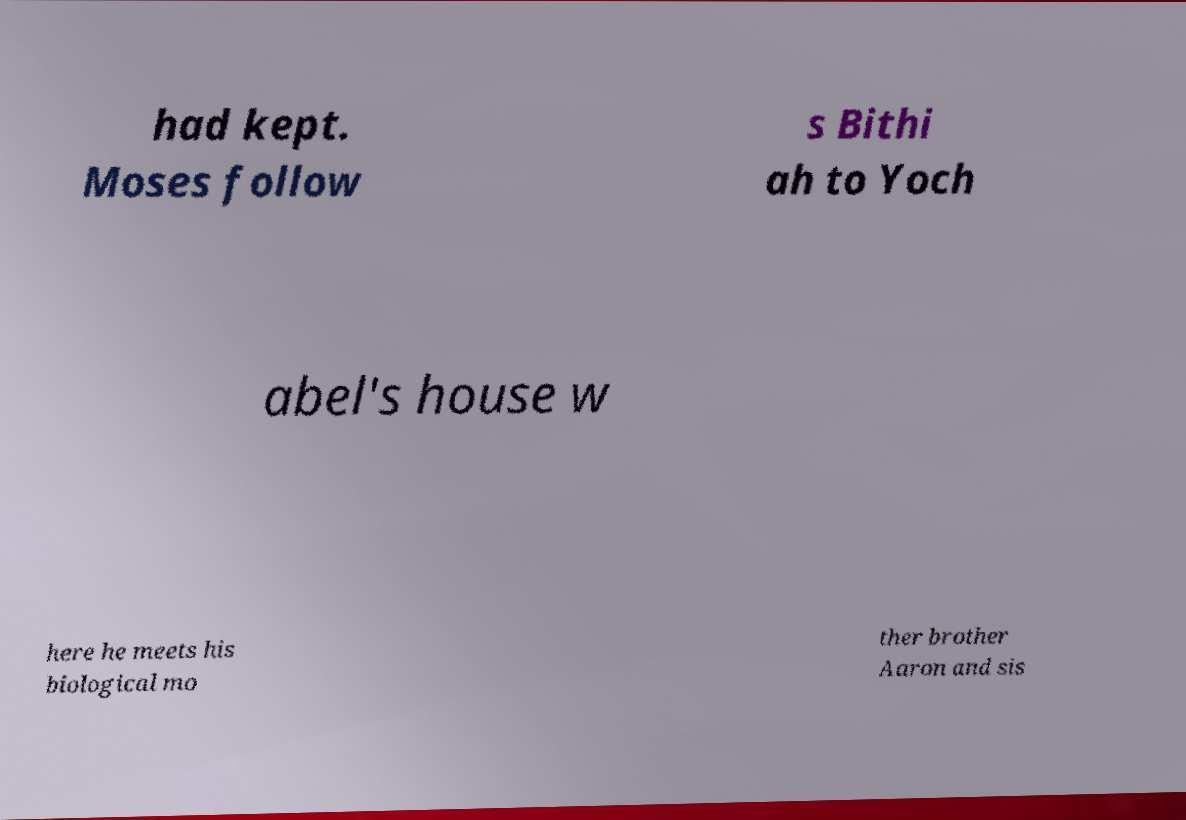Please identify and transcribe the text found in this image. had kept. Moses follow s Bithi ah to Yoch abel's house w here he meets his biological mo ther brother Aaron and sis 